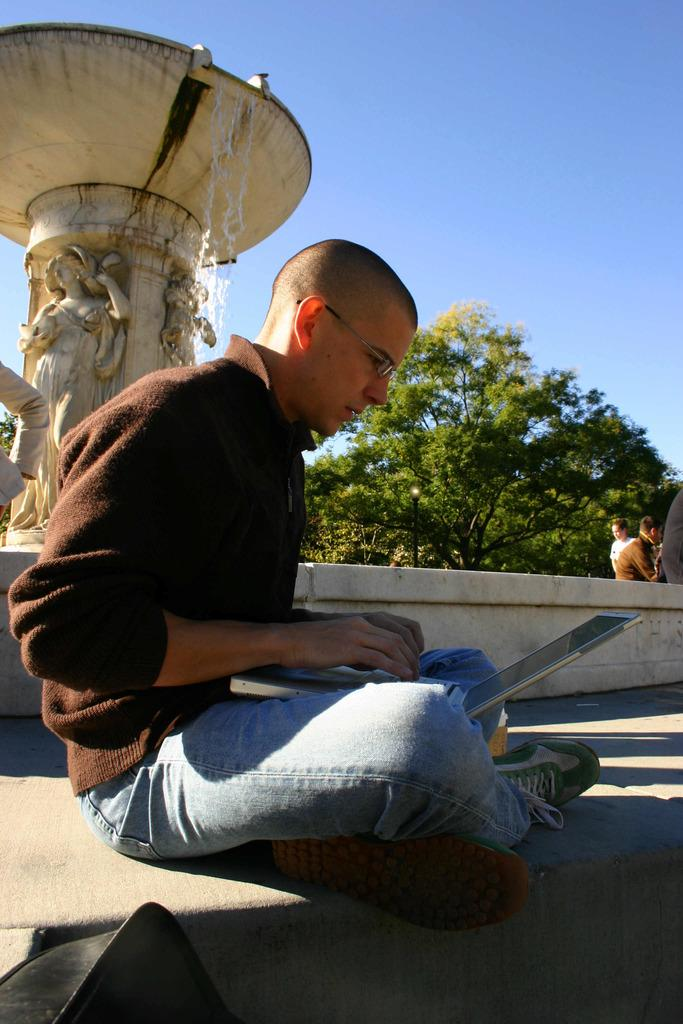What is the man in the image doing? The man is looking into a laptop. What is the man wearing in the image? The man is wearing spectacles. What can be seen in the background of the image? There are trees, persons, sculptures, and the sky visible in the background of the image. What type of brass instrument is the man playing in the image? There is no brass instrument present in the image; the man is looking into a laptop. What time of day is it in the image? The time of day cannot be determined from the image, as there is no specific indication of the time. 